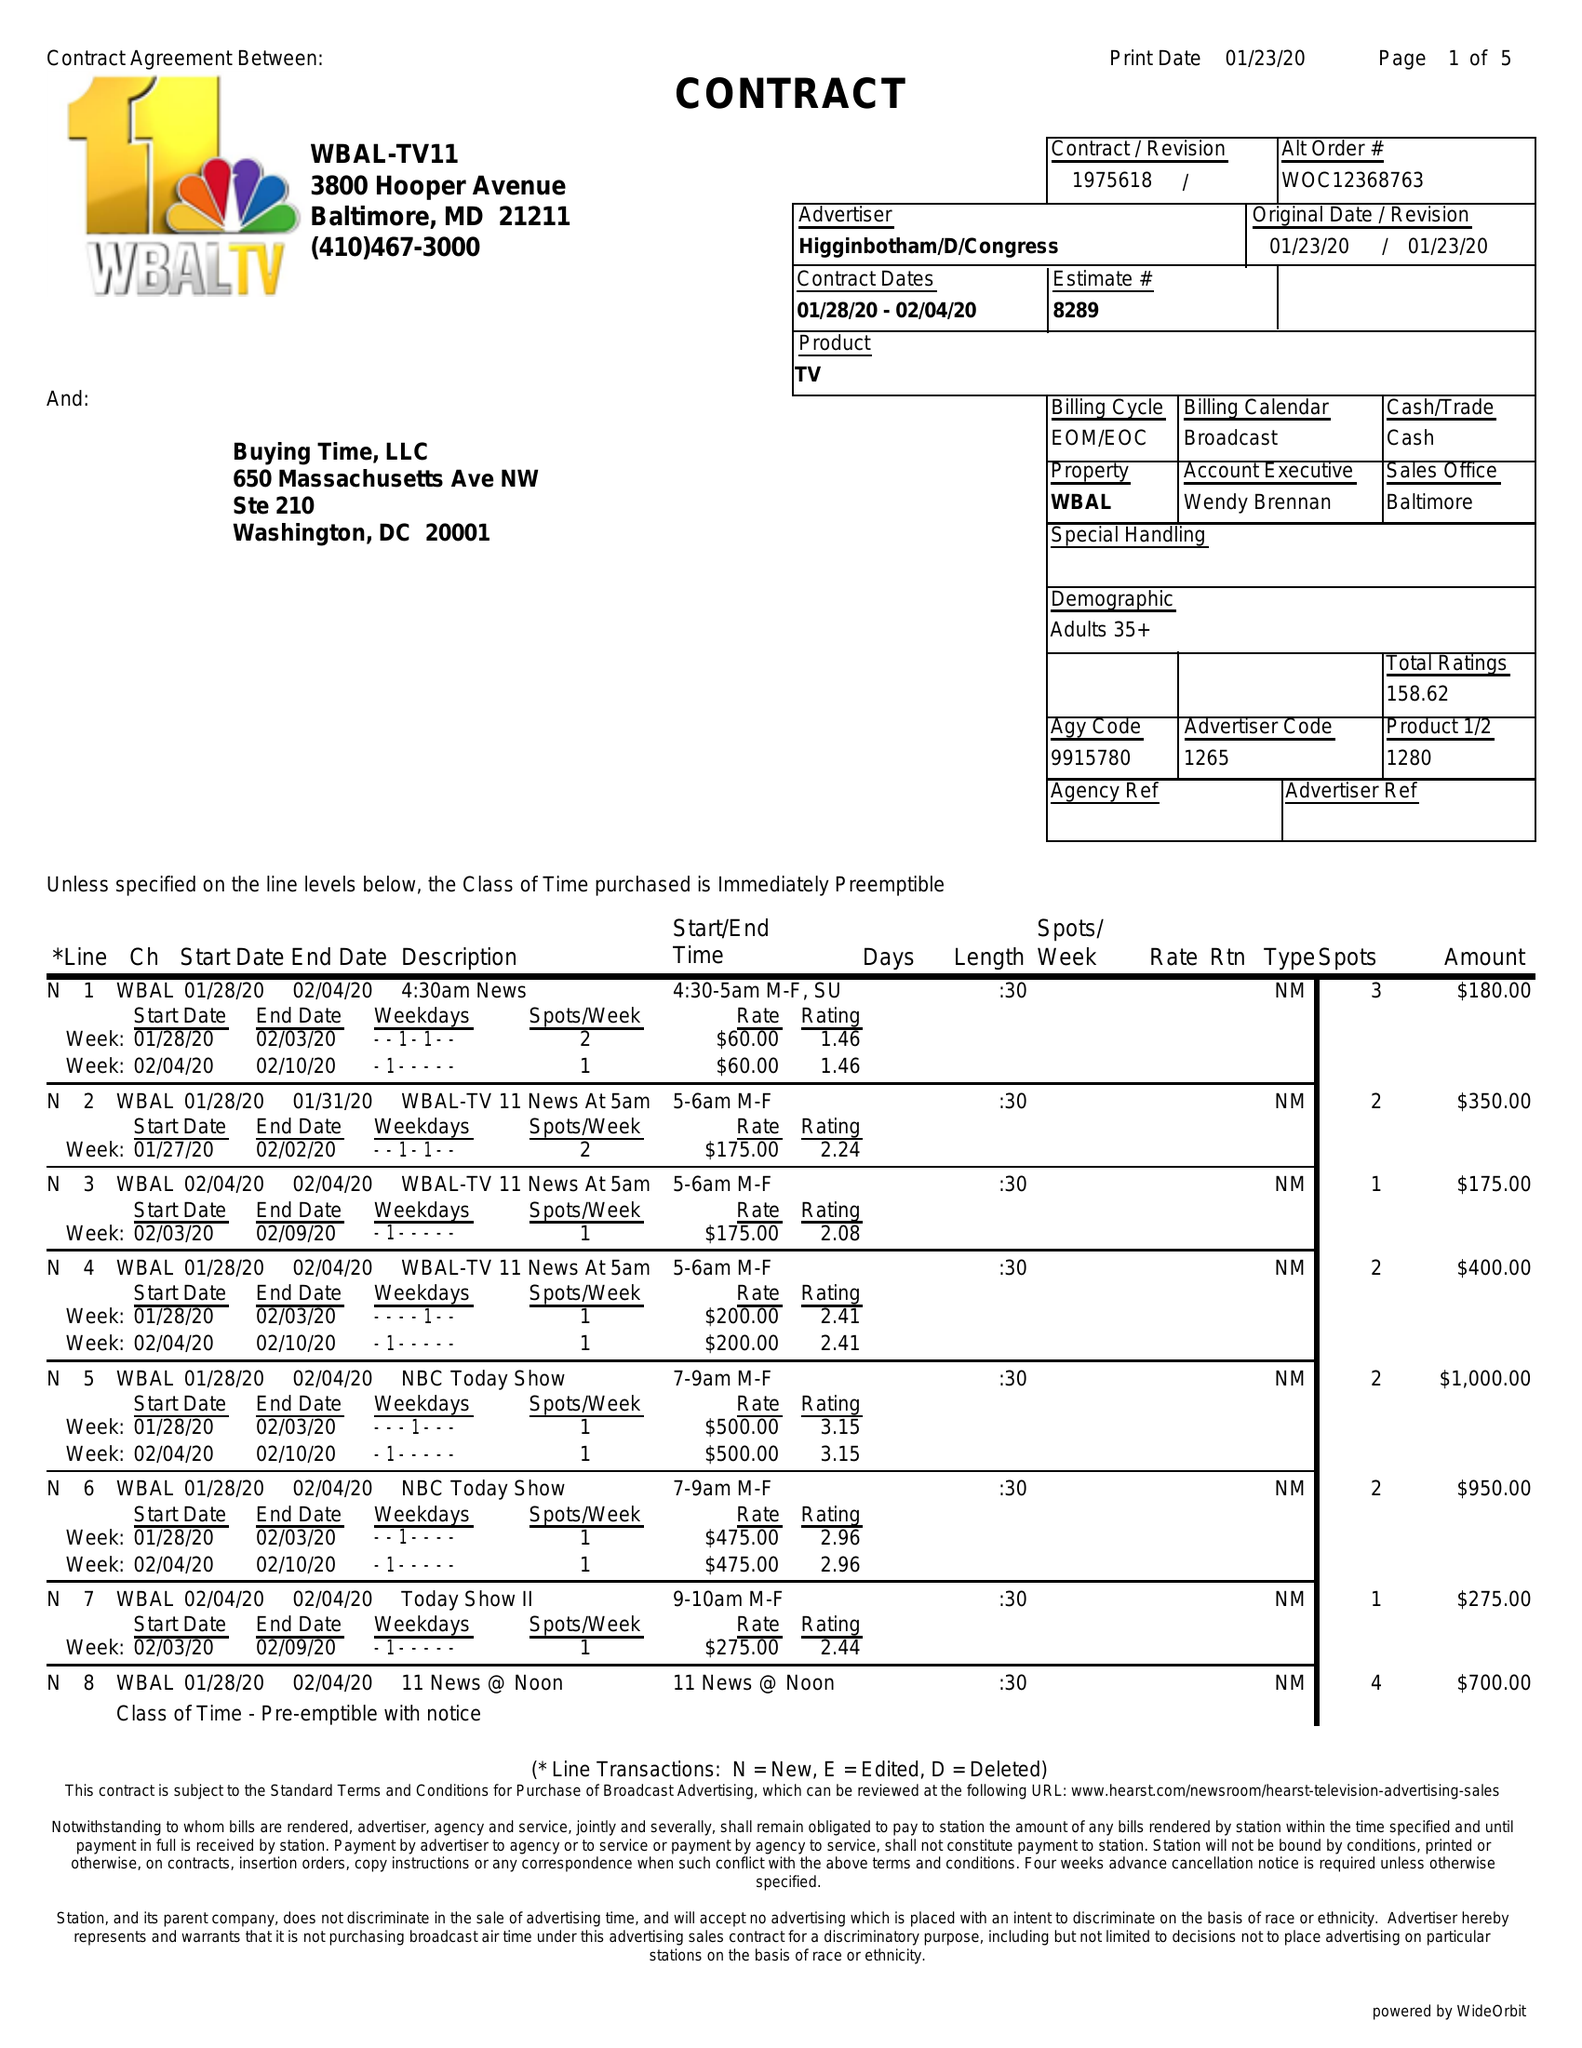What is the value for the flight_from?
Answer the question using a single word or phrase. 01/28/20 